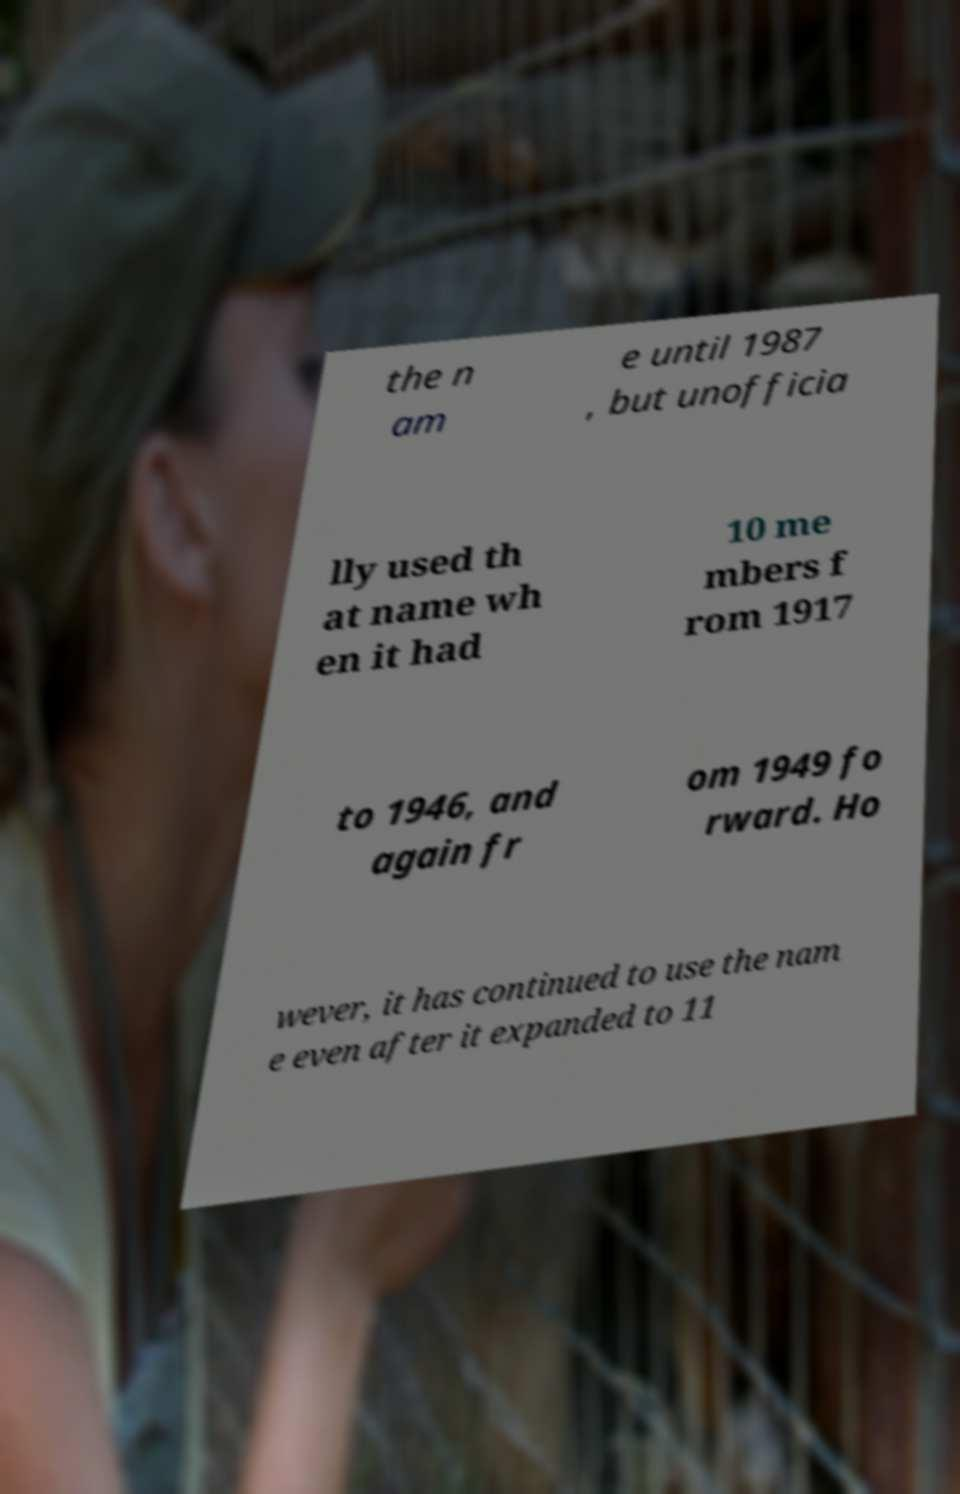Can you accurately transcribe the text from the provided image for me? the n am e until 1987 , but unofficia lly used th at name wh en it had 10 me mbers f rom 1917 to 1946, and again fr om 1949 fo rward. Ho wever, it has continued to use the nam e even after it expanded to 11 